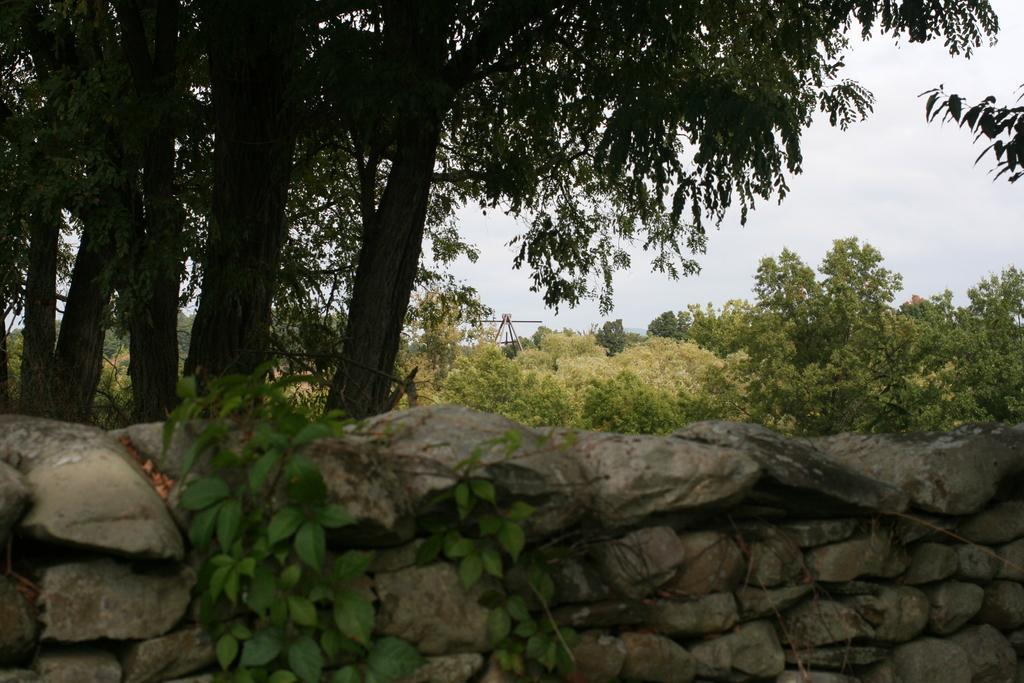Can you describe this image briefly? In the foreground of the image we can see some plants and a stone wall. In the background, we can see a group of trees, metal poles and the sky. 